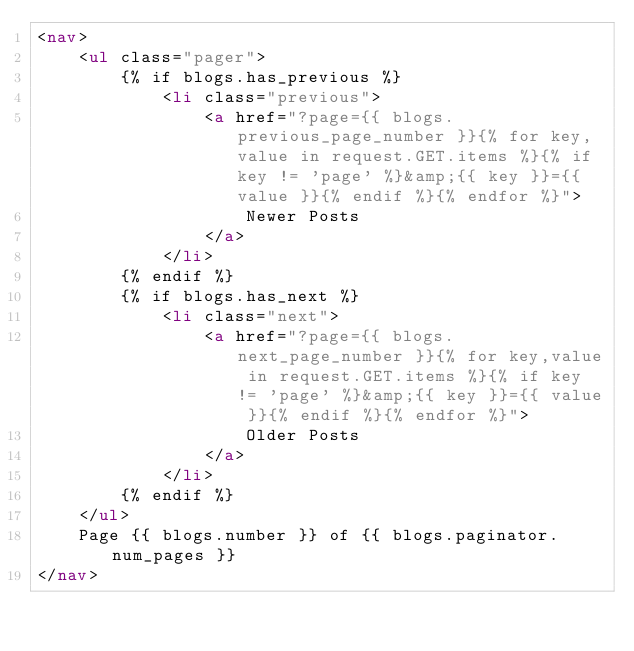Convert code to text. <code><loc_0><loc_0><loc_500><loc_500><_HTML_><nav>
    <ul class="pager">
        {% if blogs.has_previous %}
            <li class="previous">
                <a href="?page={{ blogs.previous_page_number }}{% for key,value in request.GET.items %}{% if key != 'page' %}&amp;{{ key }}={{ value }}{% endif %}{% endfor %}">
                    Newer Posts
                </a>
            </li>
        {% endif %}
        {% if blogs.has_next %}
            <li class="next">
                <a href="?page={{ blogs.next_page_number }}{% for key,value in request.GET.items %}{% if key != 'page' %}&amp;{{ key }}={{ value }}{% endif %}{% endfor %}">
                    Older Posts
                </a>
            </li>
        {% endif %}
    </ul>
    Page {{ blogs.number }} of {{ blogs.paginator.num_pages }}
</nav>
</code> 